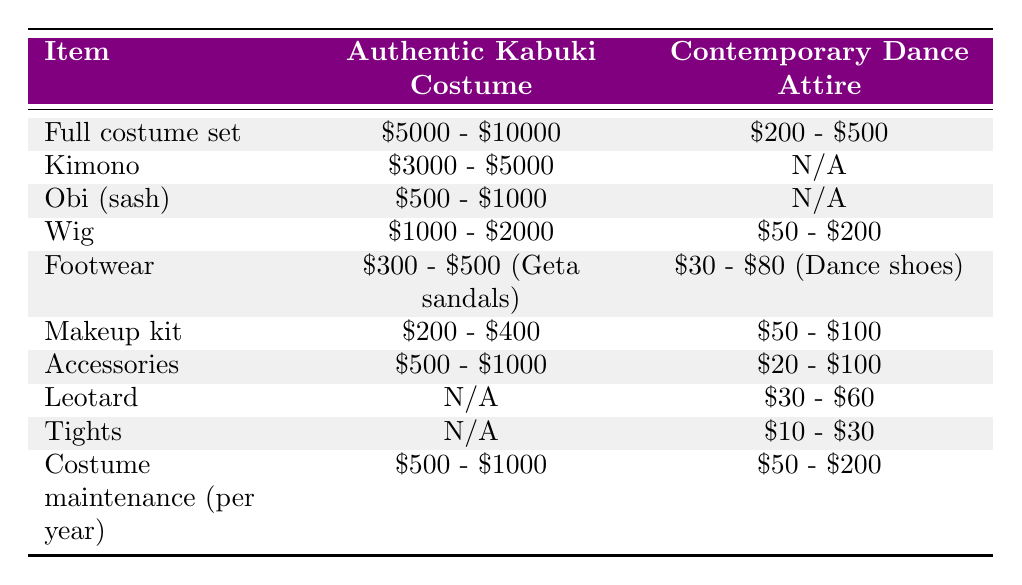What is the cost range for a full costume set of an authentic Kabuki costume? The table shows that the cost range for a full costume set of an authentic Kabuki costume is between $5000 and $10000.
Answer: $5000 - $10000 What is the price of a wig for an authentic Kabuki costume compared to contemporary dance attire? The table indicates that the wig for an authentic Kabuki costume costs between $1000 and $2000, while the wig for contemporary dance attire costs between $50 and $200.
Answer: Authentic Kabuki: $1000 - $2000, Contemporary: $50 - $200 Is the cost of footwear more affordable in contemporary dance attire or authentic Kabuki costumes? The footwear for authentic Kabuki costumes costs between $300 and $500, while contemporary dance attire footwear costs between $30 and $80. Since $30 - $80 is less than $300 - $500, contemporary dance footwear is more affordable.
Answer: Contemporary dance attire What is the difference in cost for makeup kits between the two costume types? For authentic Kabuki costumes, the makeup kit costs between $200 and $400. For contemporary dance attire, it costs between $50 and $100. To find the difference, take the higher end of both ranges: $400 - $100 = $300. So, the difference is $300.
Answer: $300 What is the average cost of maintaining an authentic Kabuki costume per year? The maintenance cost per year ranges from $500 to $1000. To find the average, we add these numbers together: $500 + $1000 = $1500, and then divide by 2, so the average is $1500 / 2 = $750.
Answer: $750 Does contemporary dance attire have specific costs for leotards and tights? According to the table, contemporary dance attire does have costs listed for both leotards ($30 - $60) and tights ($10 - $30), while authentic Kabuki costumes do not have these items listed. Therefore, the statement is true.
Answer: Yes If a dancer wanted to buy all the components of an authentic Kabuki costume, what is the minimum total cost? To find the minimum total cost for an authentic Kabuki costume, we take the lowest values from each relevant item: Full costume set ($5000) + Kimono ($3000) + Obi ($500) + Wig ($1000) + Footwear ($300) + Makeup kit ($200) + Accessories ($500). Adding these together: $5000 + $3000 + $500 + $1000 + $300 + $200 + $500 = $10000.
Answer: $10000 Are the total estimated costs for an authentic Kabuki costume and contemporary dance attire comparable? Based on the highest costs indicated in the table, the authentic Kabuki costume set can cost up to $10000, while the total for contemporary dance attire can reach around $800 if you consider the maximum of each item. Hence, they are not comparable as Kabuki costumes are significantly more expensive.
Answer: No 